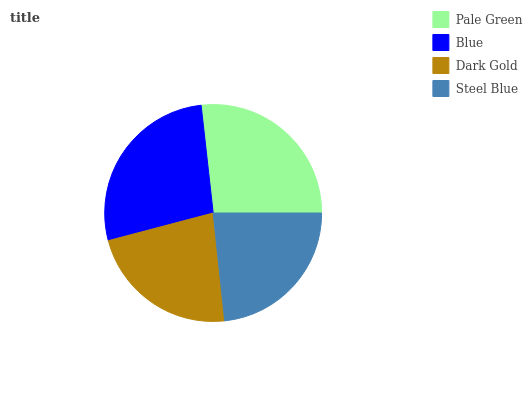Is Dark Gold the minimum?
Answer yes or no. Yes. Is Blue the maximum?
Answer yes or no. Yes. Is Blue the minimum?
Answer yes or no. No. Is Dark Gold the maximum?
Answer yes or no. No. Is Blue greater than Dark Gold?
Answer yes or no. Yes. Is Dark Gold less than Blue?
Answer yes or no. Yes. Is Dark Gold greater than Blue?
Answer yes or no. No. Is Blue less than Dark Gold?
Answer yes or no. No. Is Pale Green the high median?
Answer yes or no. Yes. Is Steel Blue the low median?
Answer yes or no. Yes. Is Dark Gold the high median?
Answer yes or no. No. Is Pale Green the low median?
Answer yes or no. No. 